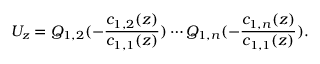Convert formula to latex. <formula><loc_0><loc_0><loc_500><loc_500>U _ { z } = Q _ { 1 , 2 } ( - \frac { c _ { 1 , 2 } ( z ) } { c _ { 1 , 1 } ( z ) } ) \cdots Q _ { 1 , n } ( - \frac { c _ { 1 , n } ( z ) } { c _ { 1 , 1 } ( z ) } ) .</formula> 